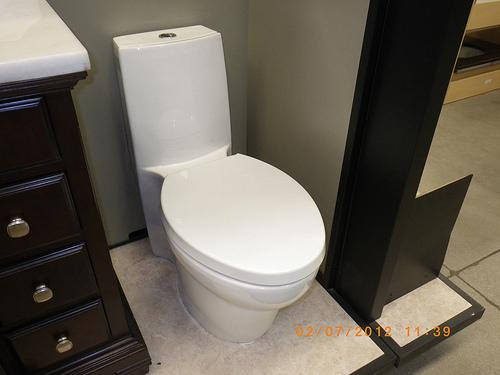Question: when was the photo taken?
Choices:
A. 2012.
B. Christmas.
C. During the birthday party.
D. 1984.
Answer with the letter. Answer: A Question: what time was the photo taken?
Choices:
A. Early morning.
B. 11:39.
C. Midnight.
D. After dinner.
Answer with the letter. Answer: B Question: what type of scene is this?
Choices:
A. Indoor.
B. Landscape.
C. Party.
D. Riot.
Answer with the letter. Answer: A 